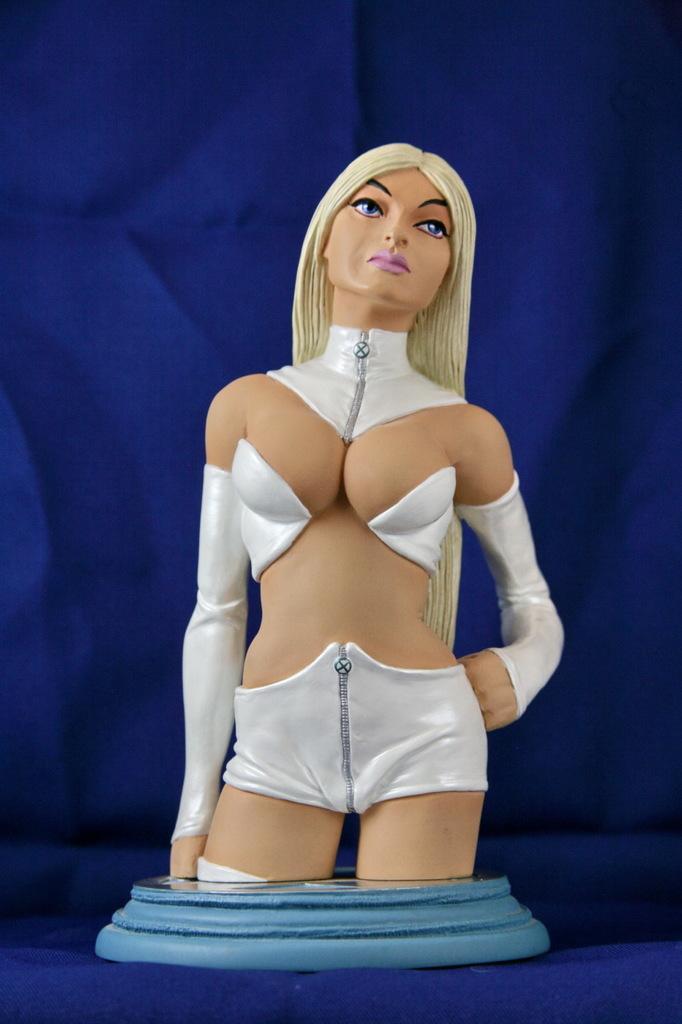In one or two sentences, can you explain what this image depicts? In the image we can see the sculpture of a woman wearing clothes and the background is blue. 